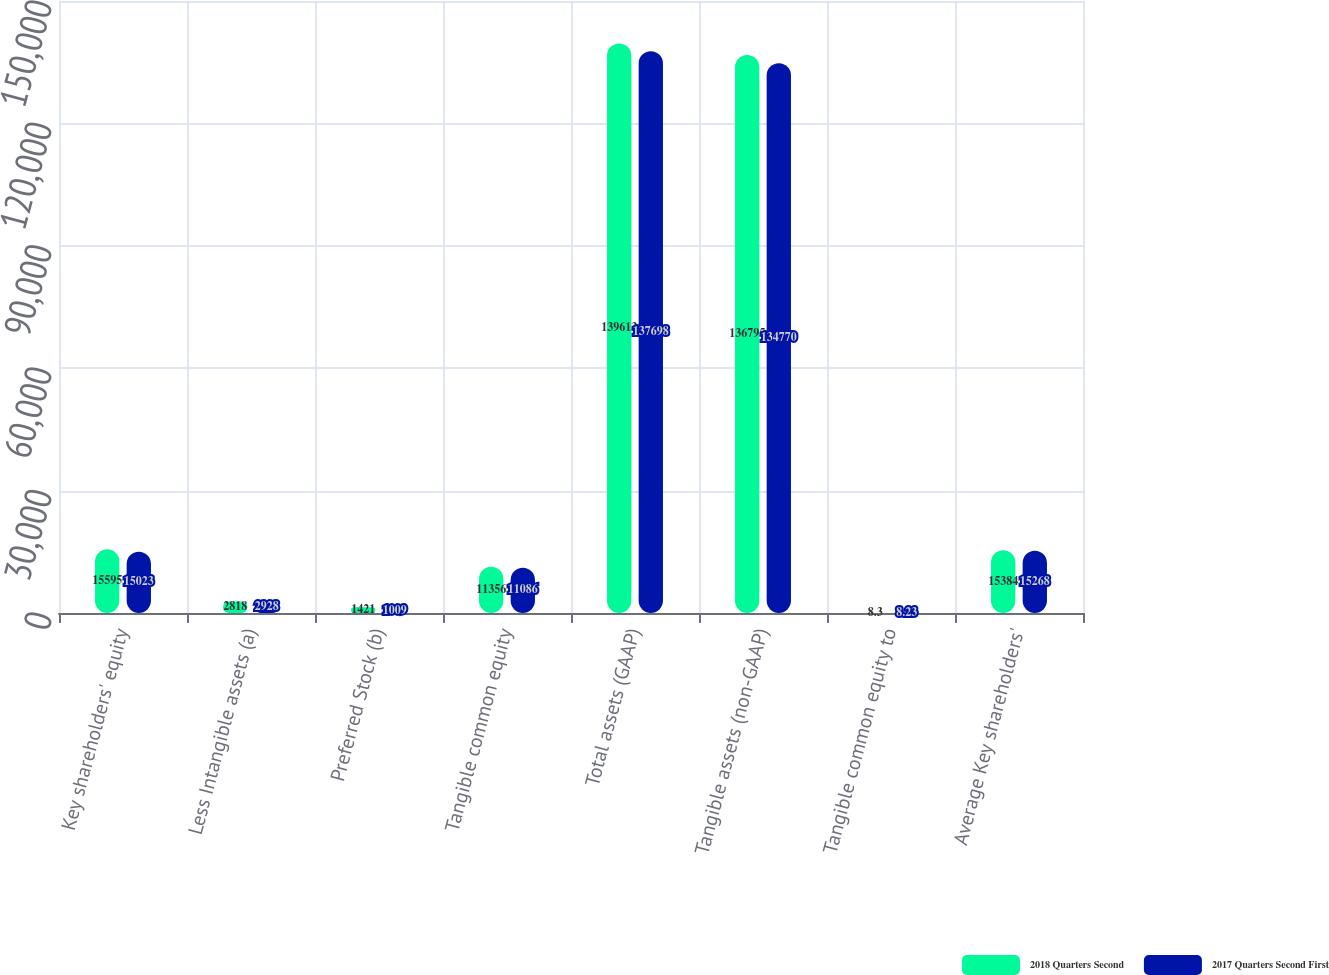<chart> <loc_0><loc_0><loc_500><loc_500><stacked_bar_chart><ecel><fcel>Key shareholders' equity<fcel>Less Intangible assets (a)<fcel>Preferred Stock (b)<fcel>Tangible common equity<fcel>Total assets (GAAP)<fcel>Tangible assets (non-GAAP)<fcel>Tangible common equity to<fcel>Average Key shareholders'<nl><fcel>2018 Quarters Second<fcel>15595<fcel>2818<fcel>1421<fcel>11356<fcel>139613<fcel>136795<fcel>8.3<fcel>15384<nl><fcel>2017 Quarters Second First<fcel>15023<fcel>2928<fcel>1009<fcel>11086<fcel>137698<fcel>134770<fcel>8.23<fcel>15268<nl></chart> 